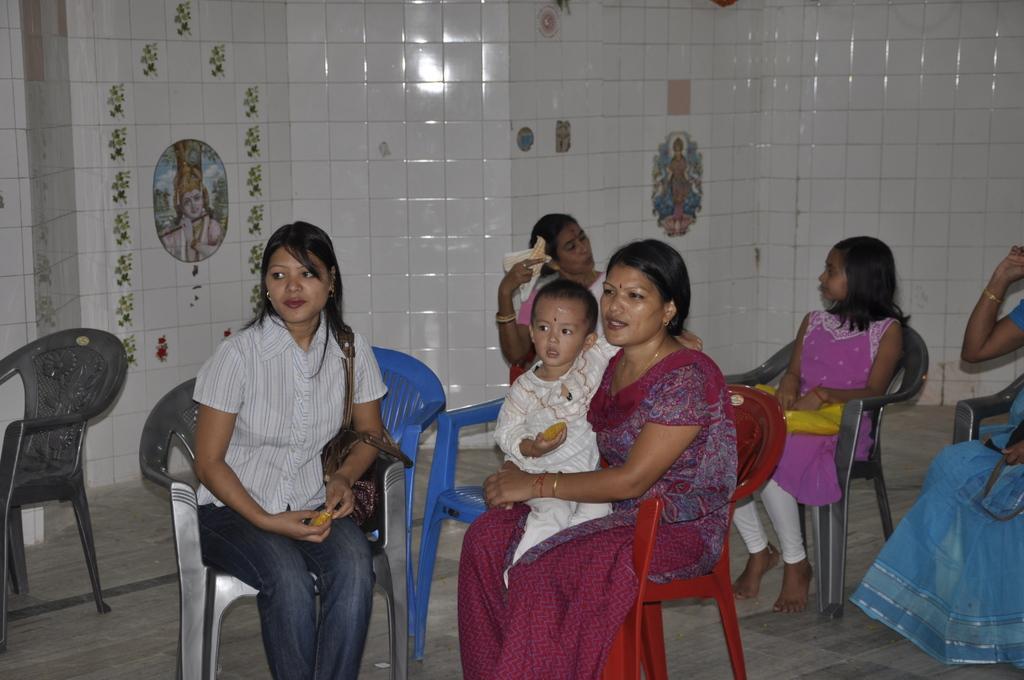Can you describe this image briefly? In this image I see 4 women who are sitting and i can also see this woman is holding a child and there is a girl over here who is sitting on the chair too. In the background i see the wall. 